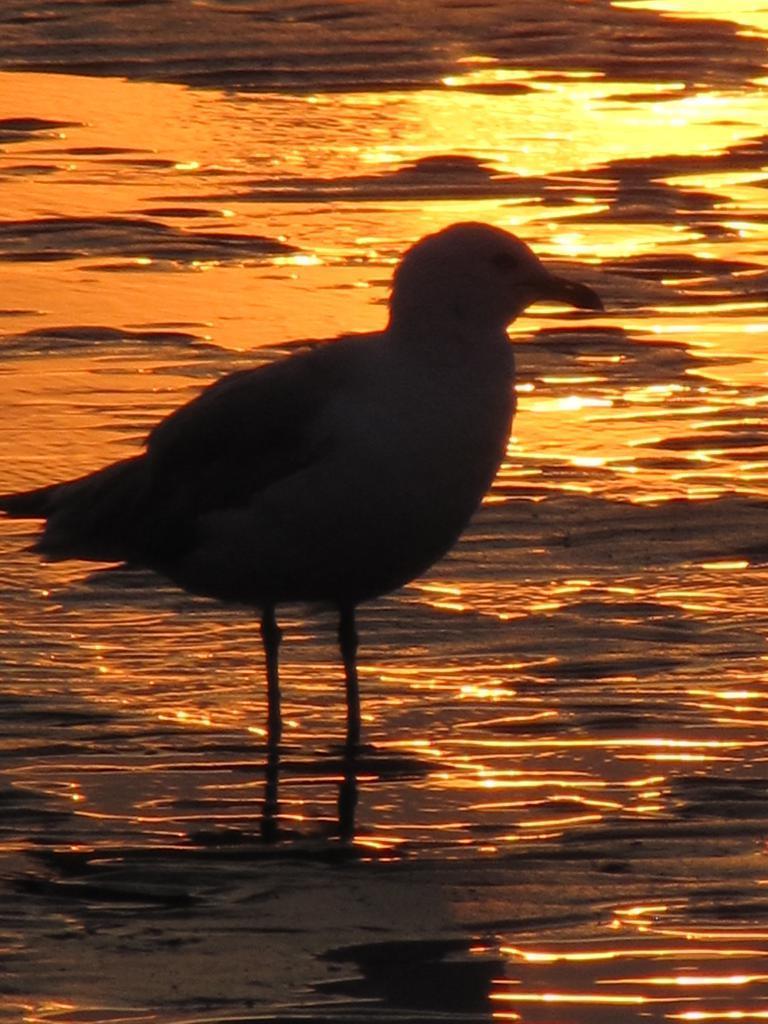Describe this image in one or two sentences. In this image we can see the bird, and the water. 